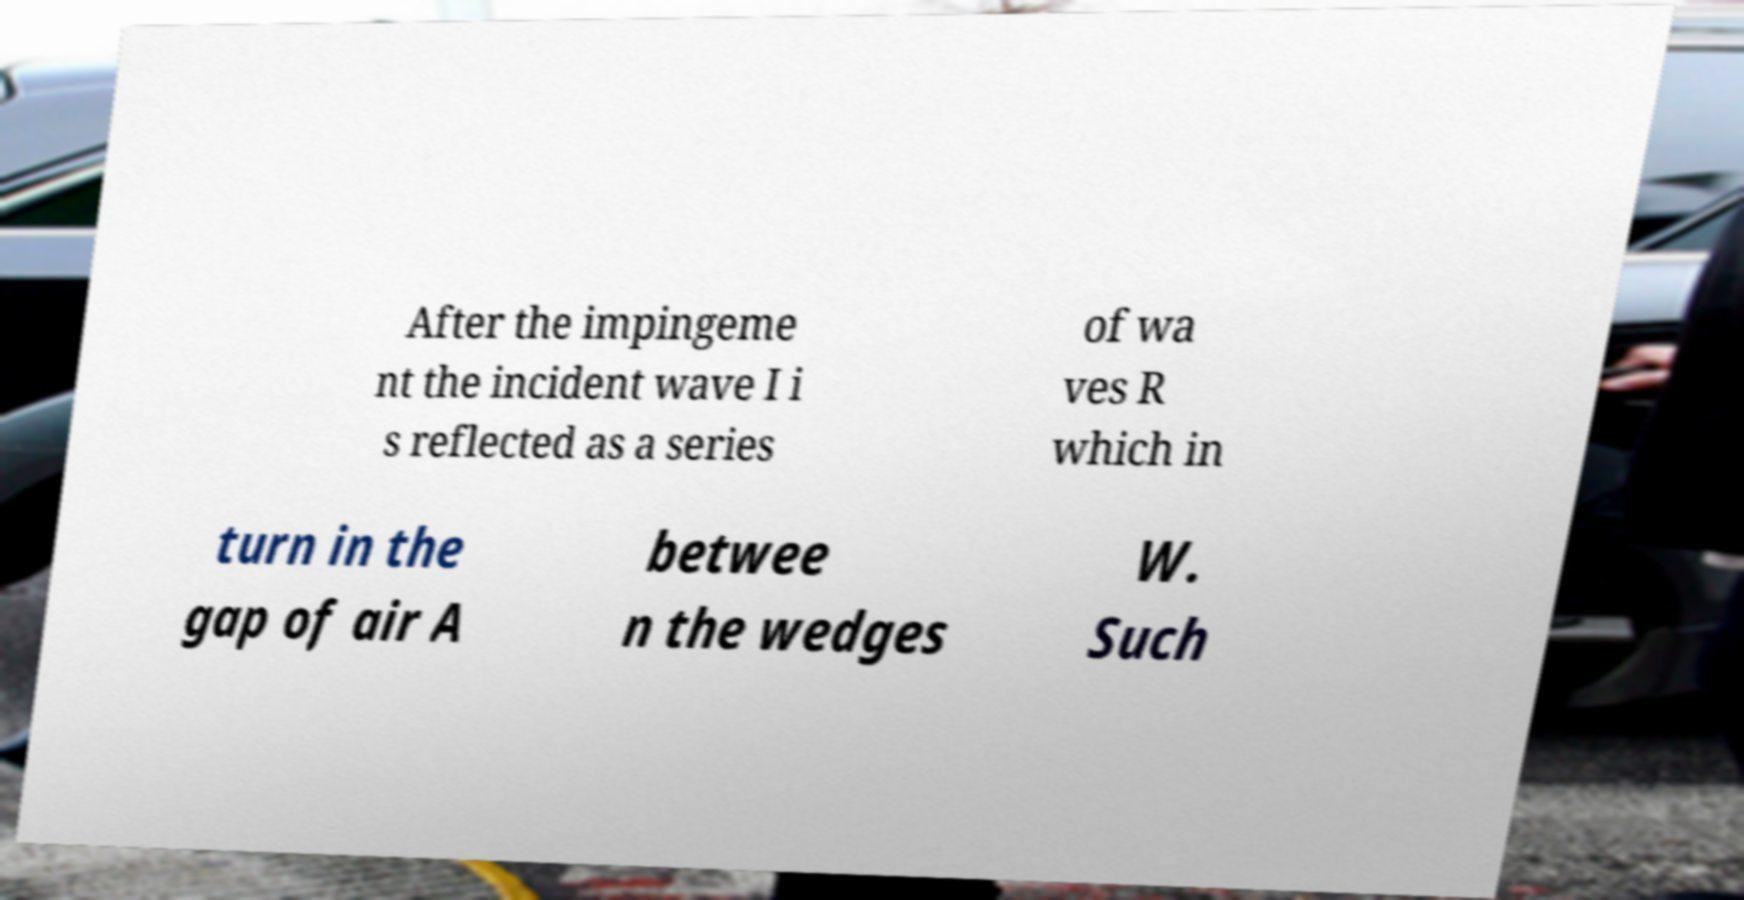Can you accurately transcribe the text from the provided image for me? After the impingeme nt the incident wave I i s reflected as a series of wa ves R which in turn in the gap of air A betwee n the wedges W. Such 